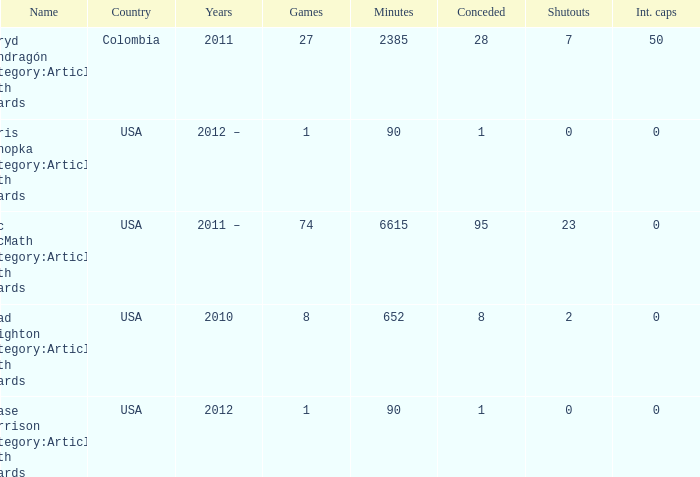What is the lowest overall amount of shutouts? 0.0. 